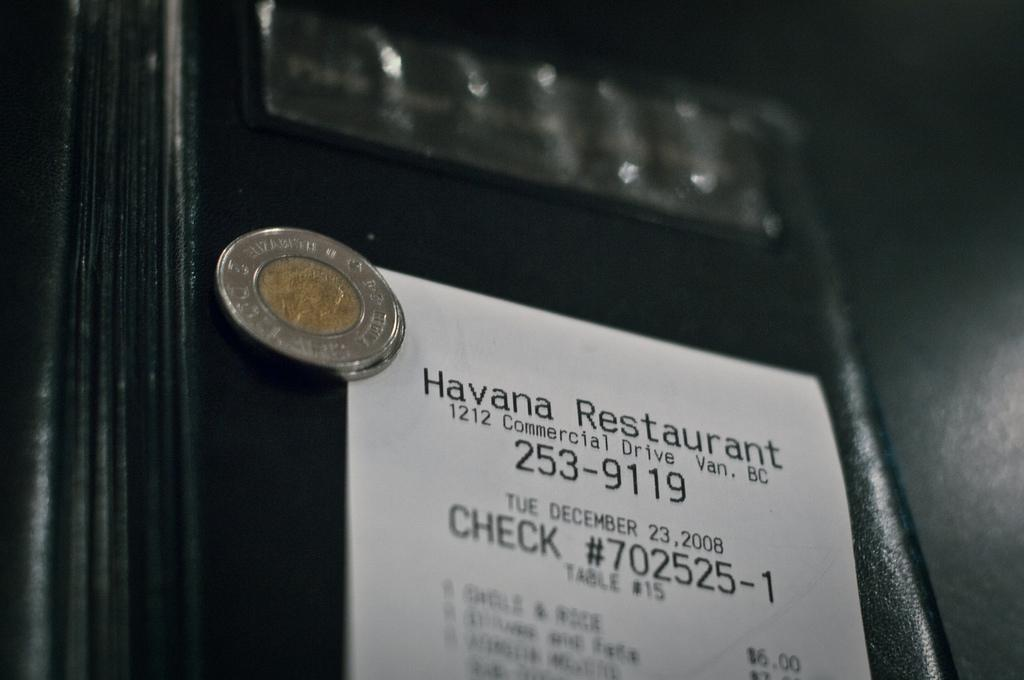<image>
Share a concise interpretation of the image provided. A white receipt from the Havana Restaurant is on top of something black 